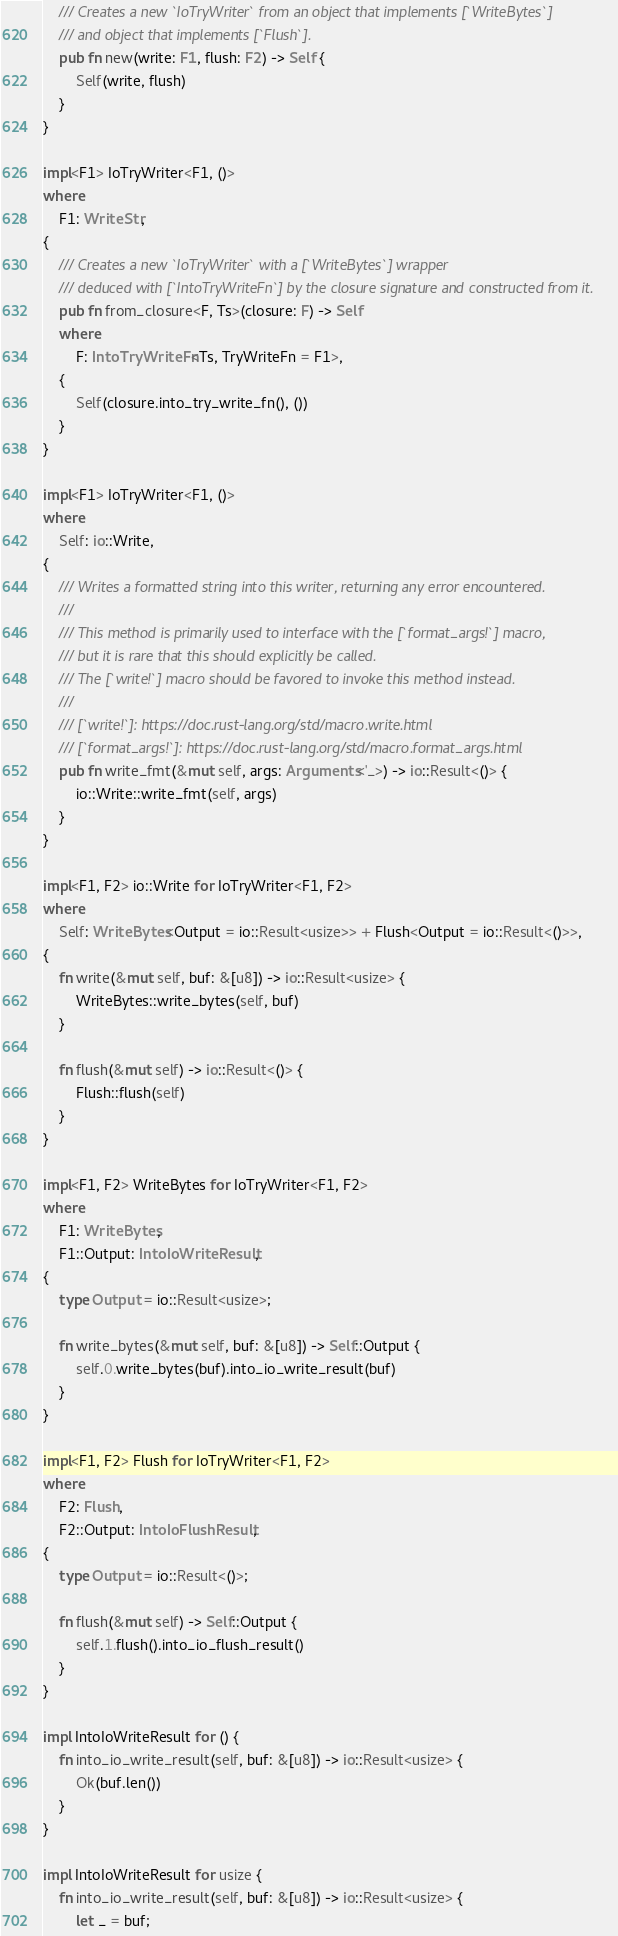Convert code to text. <code><loc_0><loc_0><loc_500><loc_500><_Rust_>    /// Creates a new `IoTryWriter` from an object that implements [`WriteBytes`]
    /// and object that implements [`Flush`].
    pub fn new(write: F1, flush: F2) -> Self {
        Self(write, flush)
    }
}

impl<F1> IoTryWriter<F1, ()>
where
    F1: WriteStr,
{
    /// Creates a new `IoTryWriter` with a [`WriteBytes`] wrapper
    /// deduced with [`IntoTryWriteFn`] by the closure signature and constructed from it.
    pub fn from_closure<F, Ts>(closure: F) -> Self
    where
        F: IntoTryWriteFn<Ts, TryWriteFn = F1>,
    {
        Self(closure.into_try_write_fn(), ())
    }
}

impl<F1> IoTryWriter<F1, ()>
where
    Self: io::Write,
{
    /// Writes a formatted string into this writer, returning any error encountered.
    ///
    /// This method is primarily used to interface with the [`format_args!`] macro,
    /// but it is rare that this should explicitly be called.
    /// The [`write!`] macro should be favored to invoke this method instead.
    ///
    /// [`write!`]: https://doc.rust-lang.org/std/macro.write.html
    /// [`format_args!`]: https://doc.rust-lang.org/std/macro.format_args.html
    pub fn write_fmt(&mut self, args: Arguments<'_>) -> io::Result<()> {
        io::Write::write_fmt(self, args)
    }
}

impl<F1, F2> io::Write for IoTryWriter<F1, F2>
where
    Self: WriteBytes<Output = io::Result<usize>> + Flush<Output = io::Result<()>>,
{
    fn write(&mut self, buf: &[u8]) -> io::Result<usize> {
        WriteBytes::write_bytes(self, buf)
    }

    fn flush(&mut self) -> io::Result<()> {
        Flush::flush(self)
    }
}

impl<F1, F2> WriteBytes for IoTryWriter<F1, F2>
where
    F1: WriteBytes,
    F1::Output: IntoIoWriteResult,
{
    type Output = io::Result<usize>;

    fn write_bytes(&mut self, buf: &[u8]) -> Self::Output {
        self.0.write_bytes(buf).into_io_write_result(buf)
    }
}

impl<F1, F2> Flush for IoTryWriter<F1, F2>
where
    F2: Flush,
    F2::Output: IntoIoFlushResult,
{
    type Output = io::Result<()>;

    fn flush(&mut self) -> Self::Output {
        self.1.flush().into_io_flush_result()
    }
}

impl IntoIoWriteResult for () {
    fn into_io_write_result(self, buf: &[u8]) -> io::Result<usize> {
        Ok(buf.len())
    }
}

impl IntoIoWriteResult for usize {
    fn into_io_write_result(self, buf: &[u8]) -> io::Result<usize> {
        let _ = buf;</code> 